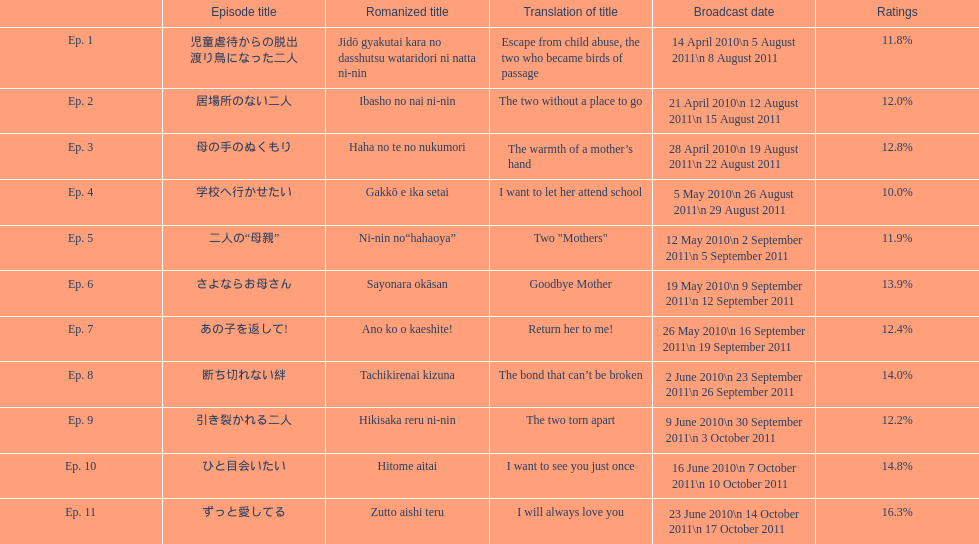How many episode are not over 14%? 8. 